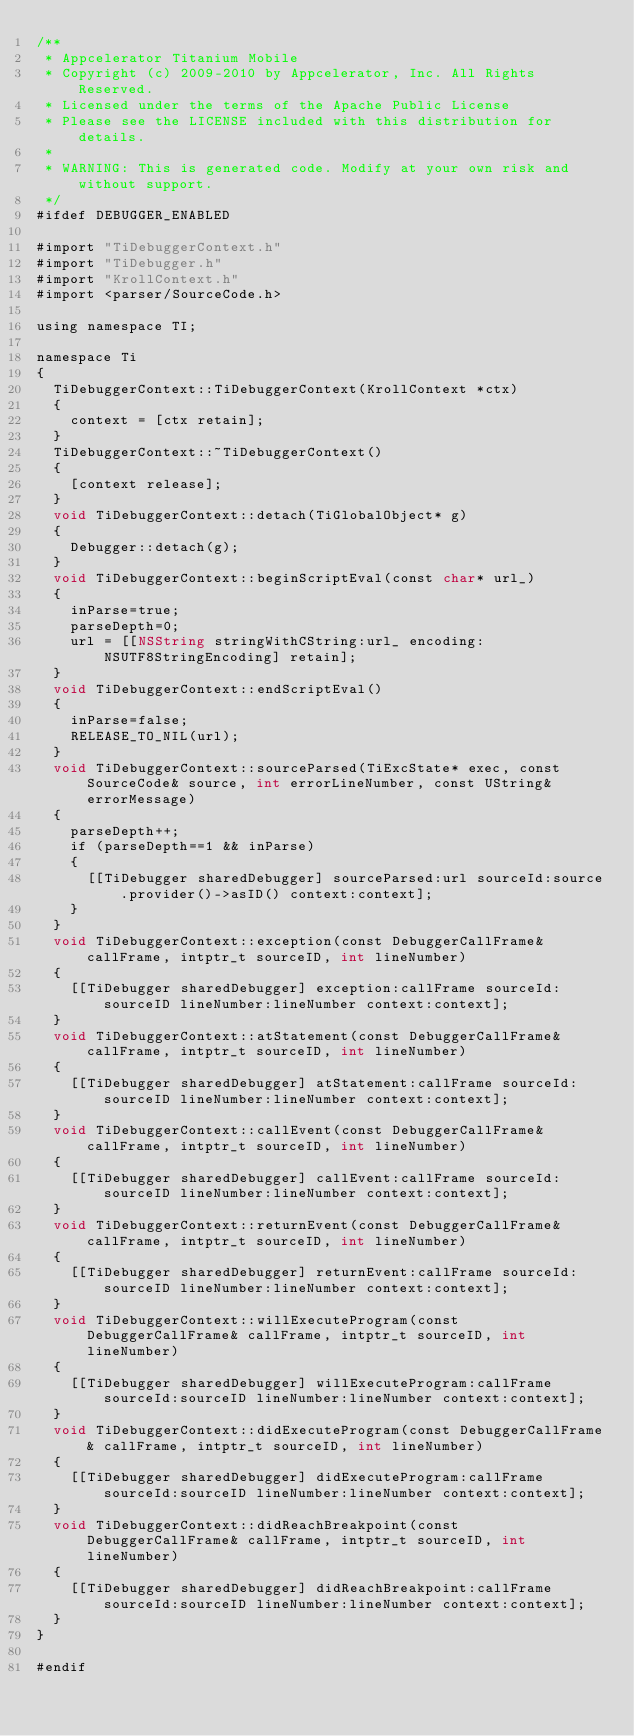<code> <loc_0><loc_0><loc_500><loc_500><_ObjectiveC_>/**
 * Appcelerator Titanium Mobile
 * Copyright (c) 2009-2010 by Appcelerator, Inc. All Rights Reserved.
 * Licensed under the terms of the Apache Public License
 * Please see the LICENSE included with this distribution for details.
 * 
 * WARNING: This is generated code. Modify at your own risk and without support.
 */
#ifdef DEBUGGER_ENABLED

#import "TiDebuggerContext.h"
#import "TiDebugger.h"
#import "KrollContext.h"
#import <parser/SourceCode.h>

using namespace TI;

namespace Ti
{
	TiDebuggerContext::TiDebuggerContext(KrollContext *ctx)
	{
		context = [ctx retain];
	}
	TiDebuggerContext::~TiDebuggerContext()
	{
		[context release];
	}
	void TiDebuggerContext::detach(TiGlobalObject* g)
	{
		Debugger::detach(g);
	}
	void TiDebuggerContext::beginScriptEval(const char* url_)
	{
		inParse=true;
		parseDepth=0;
		url = [[NSString stringWithCString:url_ encoding:NSUTF8StringEncoding] retain];
	}
	void TiDebuggerContext::endScriptEval()
	{
		inParse=false;
		RELEASE_TO_NIL(url);
	}
	void TiDebuggerContext::sourceParsed(TiExcState* exec, const SourceCode& source, int errorLineNumber, const UString& errorMessage)
	{
		parseDepth++;
		if (parseDepth==1 && inParse)
		{
			[[TiDebugger sharedDebugger] sourceParsed:url sourceId:source.provider()->asID() context:context];
		}
	}
	void TiDebuggerContext::exception(const DebuggerCallFrame& callFrame, intptr_t sourceID, int lineNumber)
	{
		[[TiDebugger sharedDebugger] exception:callFrame sourceId:sourceID lineNumber:lineNumber context:context];
	}
	void TiDebuggerContext::atStatement(const DebuggerCallFrame& callFrame, intptr_t sourceID, int lineNumber)
	{
		[[TiDebugger sharedDebugger] atStatement:callFrame sourceId:sourceID lineNumber:lineNumber context:context];
	}
	void TiDebuggerContext::callEvent(const DebuggerCallFrame& callFrame, intptr_t sourceID, int lineNumber)
	{
		[[TiDebugger sharedDebugger] callEvent:callFrame sourceId:sourceID lineNumber:lineNumber context:context];
	}
	void TiDebuggerContext::returnEvent(const DebuggerCallFrame& callFrame, intptr_t sourceID, int lineNumber)
	{
		[[TiDebugger sharedDebugger] returnEvent:callFrame sourceId:sourceID lineNumber:lineNumber context:context];
	}
	void TiDebuggerContext::willExecuteProgram(const DebuggerCallFrame& callFrame, intptr_t sourceID, int lineNumber)
	{
		[[TiDebugger sharedDebugger] willExecuteProgram:callFrame sourceId:sourceID lineNumber:lineNumber context:context];
	}
	void TiDebuggerContext::didExecuteProgram(const DebuggerCallFrame& callFrame, intptr_t sourceID, int lineNumber)
	{
		[[TiDebugger sharedDebugger] didExecuteProgram:callFrame sourceId:sourceID lineNumber:lineNumber context:context];
	}
	void TiDebuggerContext::didReachBreakpoint(const DebuggerCallFrame& callFrame, intptr_t sourceID, int lineNumber)
	{
		[[TiDebugger sharedDebugger] didReachBreakpoint:callFrame sourceId:sourceID lineNumber:lineNumber context:context];
	}
}

#endif
</code> 